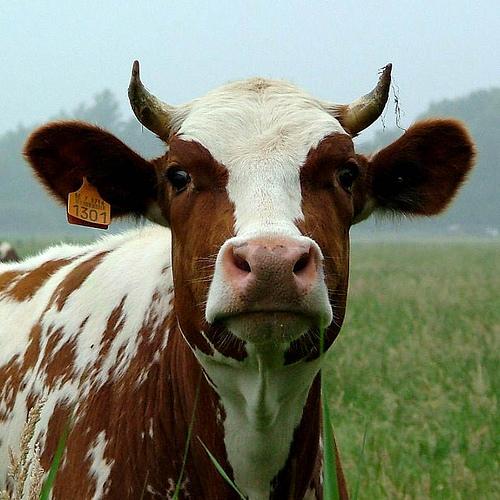How many steer are there?
Answer briefly. 1. What is the number on the tag in the cow's ear?
Short answer required. 1301. What is hanging from the cow's neck?
Short answer required. Nothing. Is this a field?
Give a very brief answer. Yes. Is the cow looking at the camera?
Quick response, please. Yes. 